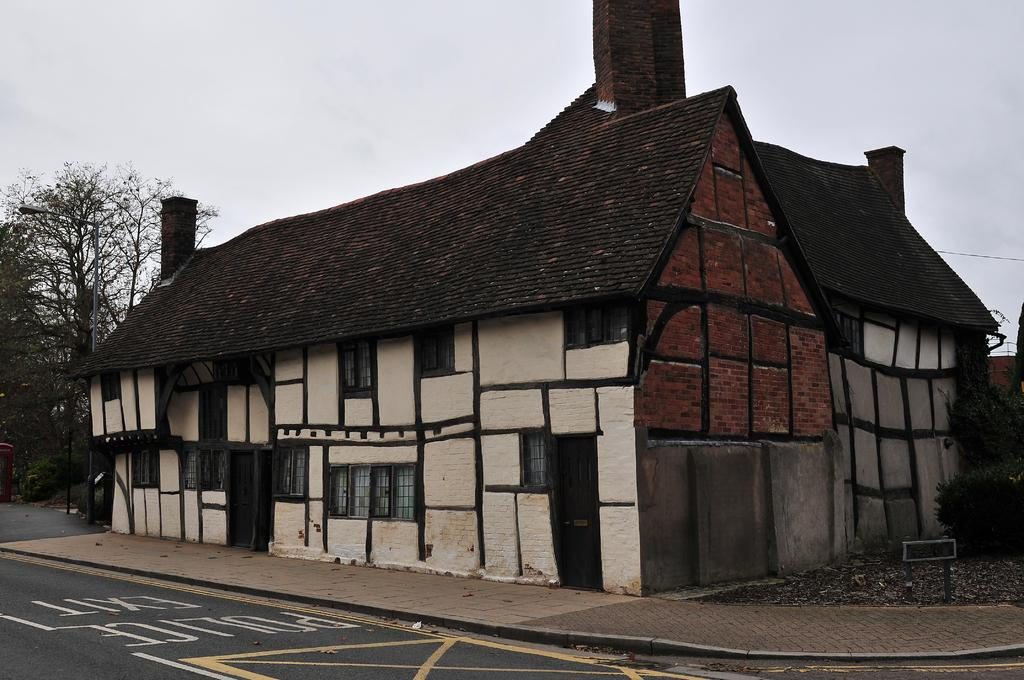What type of structure is present in the image? There is a building in the image. What else can be seen in the image besides the building? There is a road and other objects in the image. What is visible in the background of the image? The sky and trees are visible in the background of the image. What color is the wealth in the image? There is no wealth present in the image, and therefore no color can be assigned to it. 